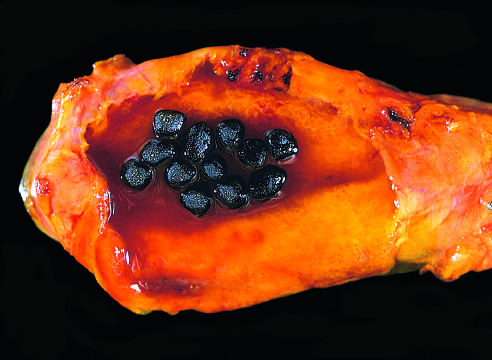re several faceted black gallstones present in this otherwise unremarkable gallbladder from a patient with a mechanical mitral valve prosthesis, leading to chronic intravascular hemolysis?
Answer the question using a single word or phrase. Yes 